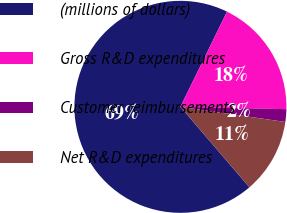Convert chart to OTSL. <chart><loc_0><loc_0><loc_500><loc_500><pie_chart><fcel>(millions of dollars)<fcel>Gross R&D expenditures<fcel>Customer reimbursements<fcel>Net R&D expenditures<nl><fcel>68.53%<fcel>18.1%<fcel>1.93%<fcel>11.44%<nl></chart> 